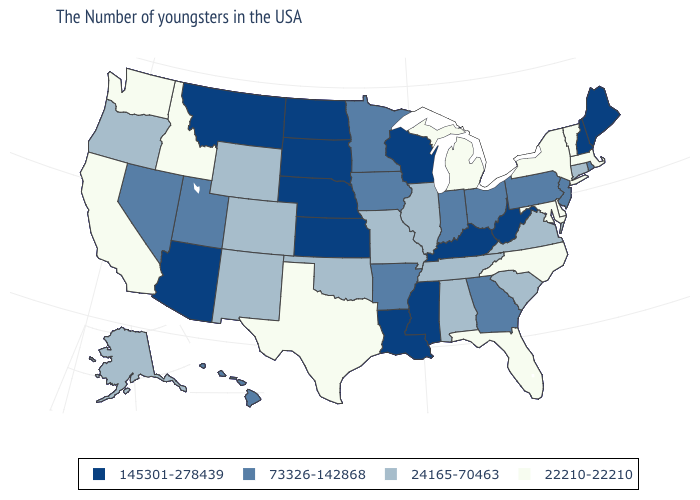Among the states that border Colorado , does Kansas have the highest value?
Short answer required. Yes. Name the states that have a value in the range 22210-22210?
Be succinct. Massachusetts, Vermont, New York, Delaware, Maryland, North Carolina, Florida, Michigan, Texas, Idaho, California, Washington. Does Minnesota have a higher value than Texas?
Write a very short answer. Yes. What is the lowest value in states that border North Carolina?
Give a very brief answer. 24165-70463. Which states have the highest value in the USA?
Quick response, please. Maine, New Hampshire, West Virginia, Kentucky, Wisconsin, Mississippi, Louisiana, Kansas, Nebraska, South Dakota, North Dakota, Montana, Arizona. What is the value of Georgia?
Short answer required. 73326-142868. What is the highest value in the South ?
Concise answer only. 145301-278439. Does Maine have the highest value in the USA?
Write a very short answer. Yes. Which states have the lowest value in the USA?
Be succinct. Massachusetts, Vermont, New York, Delaware, Maryland, North Carolina, Florida, Michigan, Texas, Idaho, California, Washington. What is the highest value in the South ?
Write a very short answer. 145301-278439. Does West Virginia have a lower value than Virginia?
Quick response, please. No. How many symbols are there in the legend?
Be succinct. 4. Does Nevada have a lower value than South Dakota?
Keep it brief. Yes. Among the states that border Kansas , which have the highest value?
Quick response, please. Nebraska. Does the map have missing data?
Concise answer only. No. 